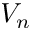<formula> <loc_0><loc_0><loc_500><loc_500>V _ { n }</formula> 